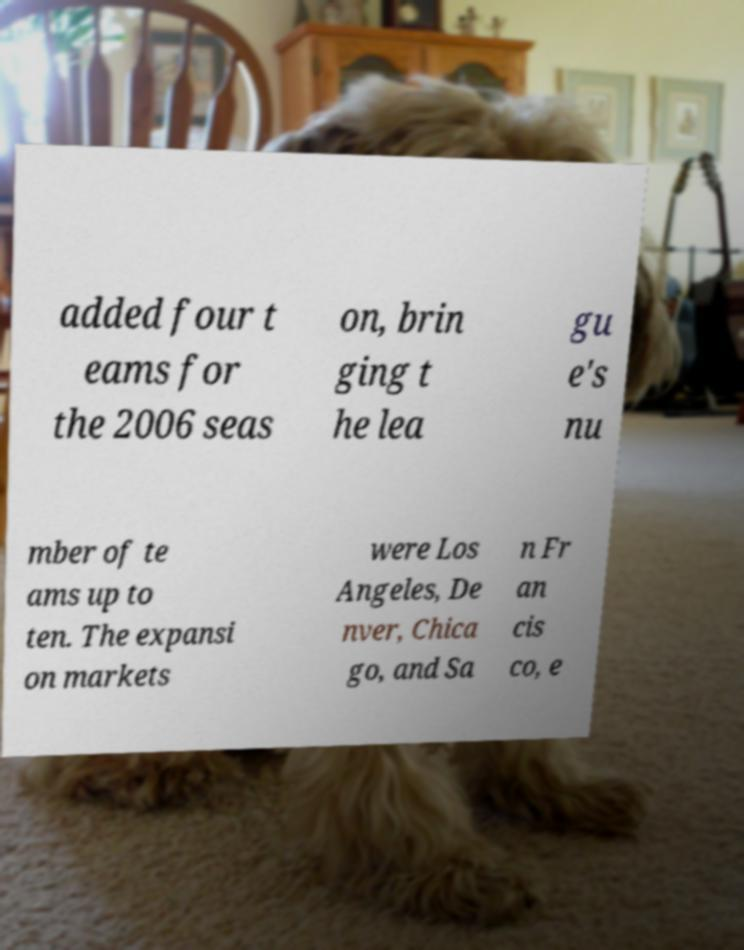Please identify and transcribe the text found in this image. added four t eams for the 2006 seas on, brin ging t he lea gu e's nu mber of te ams up to ten. The expansi on markets were Los Angeles, De nver, Chica go, and Sa n Fr an cis co, e 